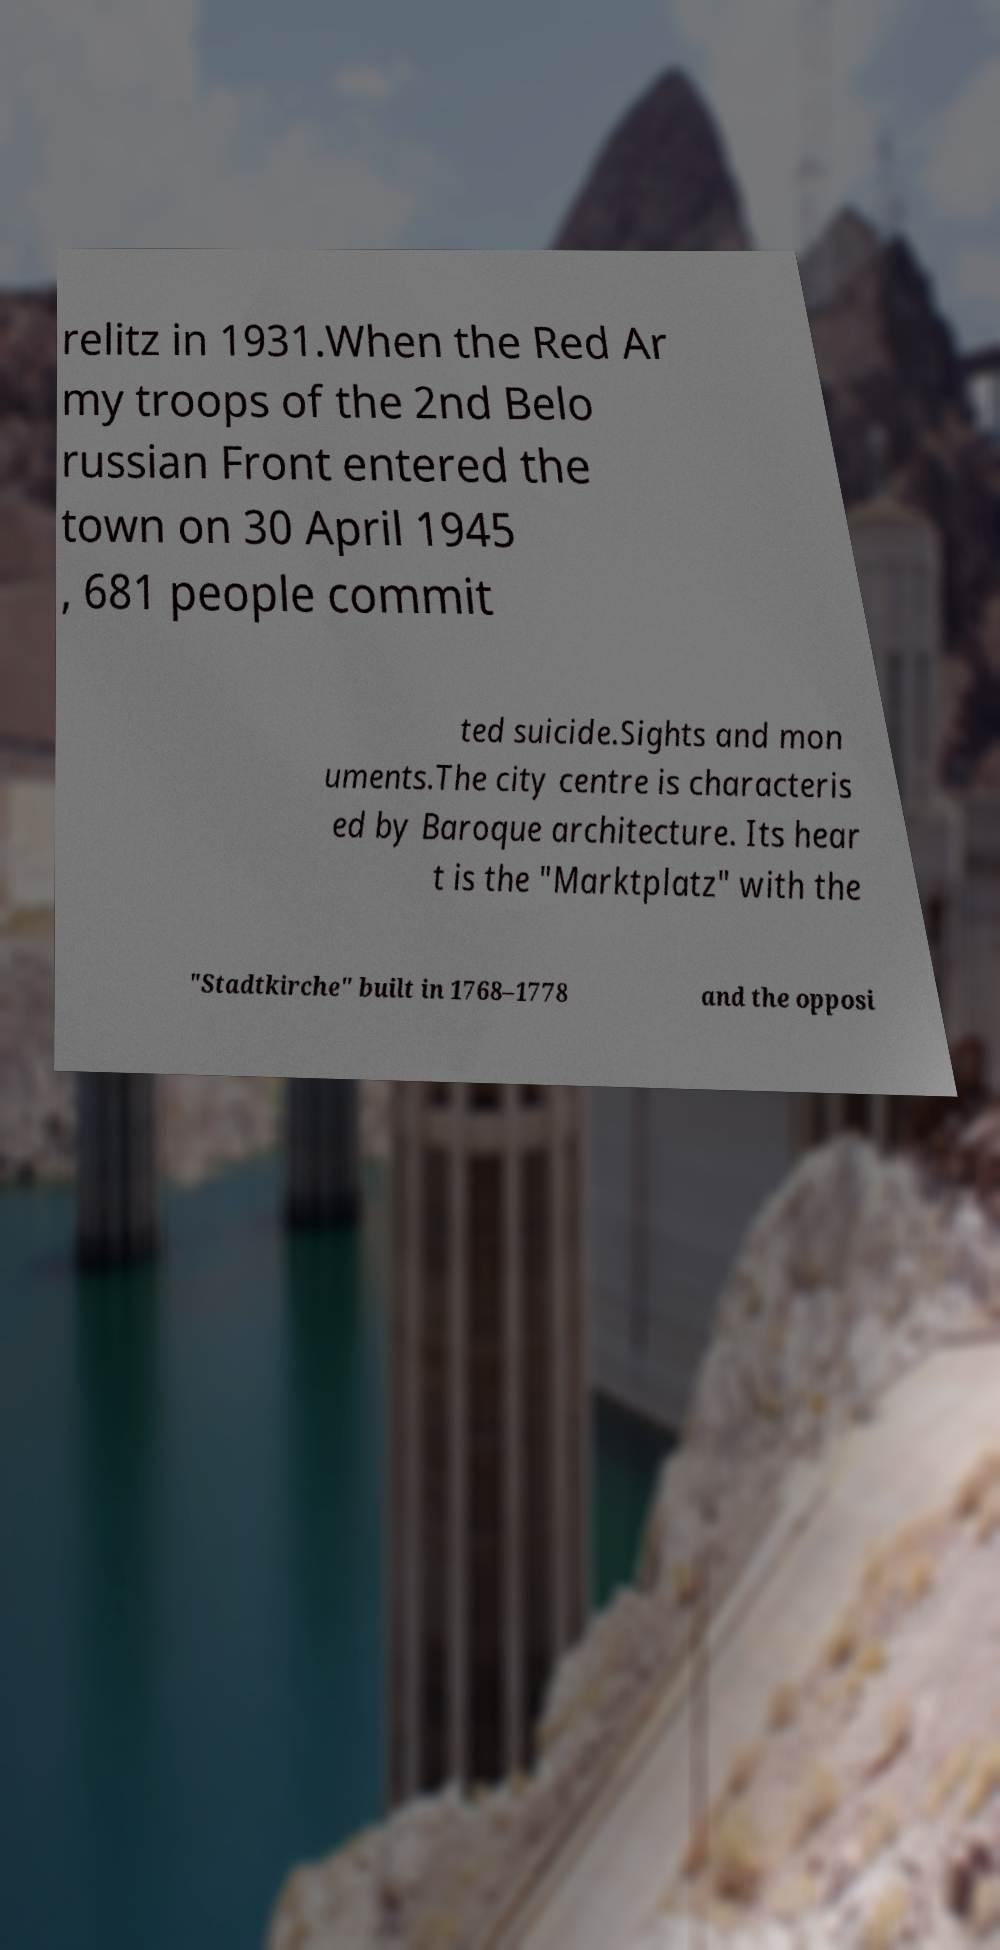What messages or text are displayed in this image? I need them in a readable, typed format. relitz in 1931.When the Red Ar my troops of the 2nd Belo russian Front entered the town on 30 April 1945 , 681 people commit ted suicide.Sights and mon uments.The city centre is characteris ed by Baroque architecture. Its hear t is the "Marktplatz" with the "Stadtkirche" built in 1768–1778 and the opposi 